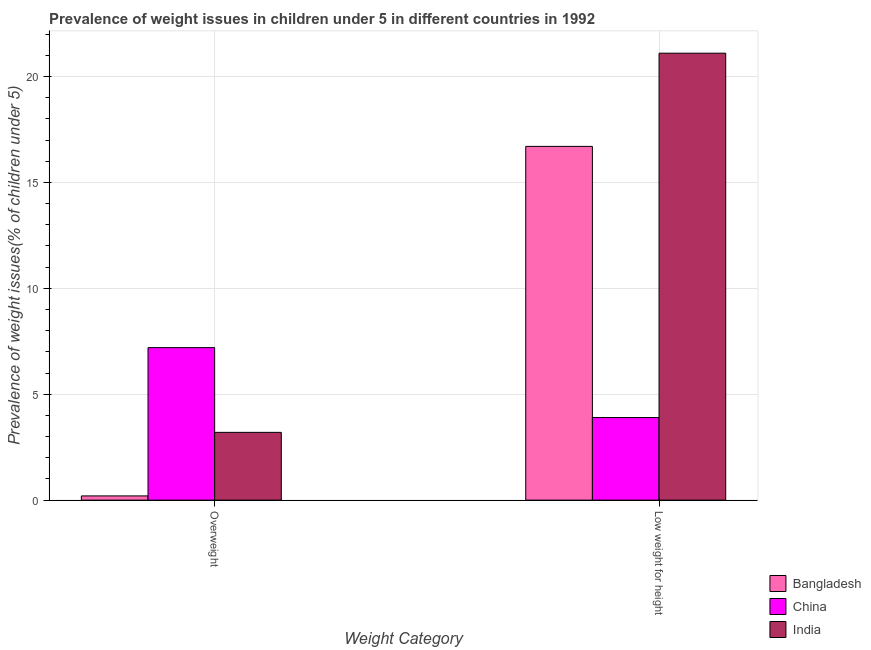Are the number of bars on each tick of the X-axis equal?
Keep it short and to the point. Yes. What is the label of the 1st group of bars from the left?
Provide a succinct answer. Overweight. What is the percentage of overweight children in China?
Offer a very short reply. 7.2. Across all countries, what is the maximum percentage of overweight children?
Ensure brevity in your answer.  7.2. Across all countries, what is the minimum percentage of overweight children?
Offer a terse response. 0.2. In which country was the percentage of underweight children maximum?
Your response must be concise. India. In which country was the percentage of overweight children minimum?
Keep it short and to the point. Bangladesh. What is the total percentage of underweight children in the graph?
Offer a very short reply. 41.7. What is the difference between the percentage of overweight children in Bangladesh and that in India?
Ensure brevity in your answer.  -3. What is the difference between the percentage of underweight children in India and the percentage of overweight children in China?
Keep it short and to the point. 13.9. What is the average percentage of underweight children per country?
Your answer should be very brief. 13.9. What is the difference between the percentage of underweight children and percentage of overweight children in India?
Give a very brief answer. 17.9. What is the ratio of the percentage of underweight children in Bangladesh to that in China?
Offer a very short reply. 4.28. What does the 3rd bar from the left in Low weight for height represents?
Make the answer very short. India. How many bars are there?
Ensure brevity in your answer.  6. What is the difference between two consecutive major ticks on the Y-axis?
Your response must be concise. 5. What is the title of the graph?
Make the answer very short. Prevalence of weight issues in children under 5 in different countries in 1992. Does "Sweden" appear as one of the legend labels in the graph?
Your answer should be very brief. No. What is the label or title of the X-axis?
Give a very brief answer. Weight Category. What is the label or title of the Y-axis?
Keep it short and to the point. Prevalence of weight issues(% of children under 5). What is the Prevalence of weight issues(% of children under 5) in Bangladesh in Overweight?
Give a very brief answer. 0.2. What is the Prevalence of weight issues(% of children under 5) in China in Overweight?
Your answer should be very brief. 7.2. What is the Prevalence of weight issues(% of children under 5) of India in Overweight?
Keep it short and to the point. 3.2. What is the Prevalence of weight issues(% of children under 5) of Bangladesh in Low weight for height?
Your answer should be very brief. 16.7. What is the Prevalence of weight issues(% of children under 5) in China in Low weight for height?
Ensure brevity in your answer.  3.9. What is the Prevalence of weight issues(% of children under 5) of India in Low weight for height?
Your answer should be compact. 21.1. Across all Weight Category, what is the maximum Prevalence of weight issues(% of children under 5) of Bangladesh?
Keep it short and to the point. 16.7. Across all Weight Category, what is the maximum Prevalence of weight issues(% of children under 5) in China?
Provide a succinct answer. 7.2. Across all Weight Category, what is the maximum Prevalence of weight issues(% of children under 5) of India?
Keep it short and to the point. 21.1. Across all Weight Category, what is the minimum Prevalence of weight issues(% of children under 5) of Bangladesh?
Provide a succinct answer. 0.2. Across all Weight Category, what is the minimum Prevalence of weight issues(% of children under 5) in China?
Keep it short and to the point. 3.9. Across all Weight Category, what is the minimum Prevalence of weight issues(% of children under 5) in India?
Your answer should be very brief. 3.2. What is the total Prevalence of weight issues(% of children under 5) of Bangladesh in the graph?
Make the answer very short. 16.9. What is the total Prevalence of weight issues(% of children under 5) in India in the graph?
Make the answer very short. 24.3. What is the difference between the Prevalence of weight issues(% of children under 5) of Bangladesh in Overweight and that in Low weight for height?
Your answer should be compact. -16.5. What is the difference between the Prevalence of weight issues(% of children under 5) in China in Overweight and that in Low weight for height?
Your answer should be very brief. 3.3. What is the difference between the Prevalence of weight issues(% of children under 5) in India in Overweight and that in Low weight for height?
Your answer should be compact. -17.9. What is the difference between the Prevalence of weight issues(% of children under 5) of Bangladesh in Overweight and the Prevalence of weight issues(% of children under 5) of China in Low weight for height?
Offer a terse response. -3.7. What is the difference between the Prevalence of weight issues(% of children under 5) in Bangladesh in Overweight and the Prevalence of weight issues(% of children under 5) in India in Low weight for height?
Offer a very short reply. -20.9. What is the difference between the Prevalence of weight issues(% of children under 5) in China in Overweight and the Prevalence of weight issues(% of children under 5) in India in Low weight for height?
Keep it short and to the point. -13.9. What is the average Prevalence of weight issues(% of children under 5) of Bangladesh per Weight Category?
Ensure brevity in your answer.  8.45. What is the average Prevalence of weight issues(% of children under 5) of China per Weight Category?
Make the answer very short. 5.55. What is the average Prevalence of weight issues(% of children under 5) in India per Weight Category?
Ensure brevity in your answer.  12.15. What is the difference between the Prevalence of weight issues(% of children under 5) of Bangladesh and Prevalence of weight issues(% of children under 5) of China in Overweight?
Give a very brief answer. -7. What is the difference between the Prevalence of weight issues(% of children under 5) in China and Prevalence of weight issues(% of children under 5) in India in Overweight?
Your response must be concise. 4. What is the difference between the Prevalence of weight issues(% of children under 5) of Bangladesh and Prevalence of weight issues(% of children under 5) of China in Low weight for height?
Provide a short and direct response. 12.8. What is the difference between the Prevalence of weight issues(% of children under 5) in Bangladesh and Prevalence of weight issues(% of children under 5) in India in Low weight for height?
Provide a short and direct response. -4.4. What is the difference between the Prevalence of weight issues(% of children under 5) of China and Prevalence of weight issues(% of children under 5) of India in Low weight for height?
Offer a terse response. -17.2. What is the ratio of the Prevalence of weight issues(% of children under 5) of Bangladesh in Overweight to that in Low weight for height?
Your answer should be very brief. 0.01. What is the ratio of the Prevalence of weight issues(% of children under 5) in China in Overweight to that in Low weight for height?
Your answer should be compact. 1.85. What is the ratio of the Prevalence of weight issues(% of children under 5) in India in Overweight to that in Low weight for height?
Keep it short and to the point. 0.15. What is the difference between the highest and the second highest Prevalence of weight issues(% of children under 5) of Bangladesh?
Offer a terse response. 16.5. What is the difference between the highest and the lowest Prevalence of weight issues(% of children under 5) in Bangladesh?
Offer a very short reply. 16.5. What is the difference between the highest and the lowest Prevalence of weight issues(% of children under 5) of India?
Ensure brevity in your answer.  17.9. 